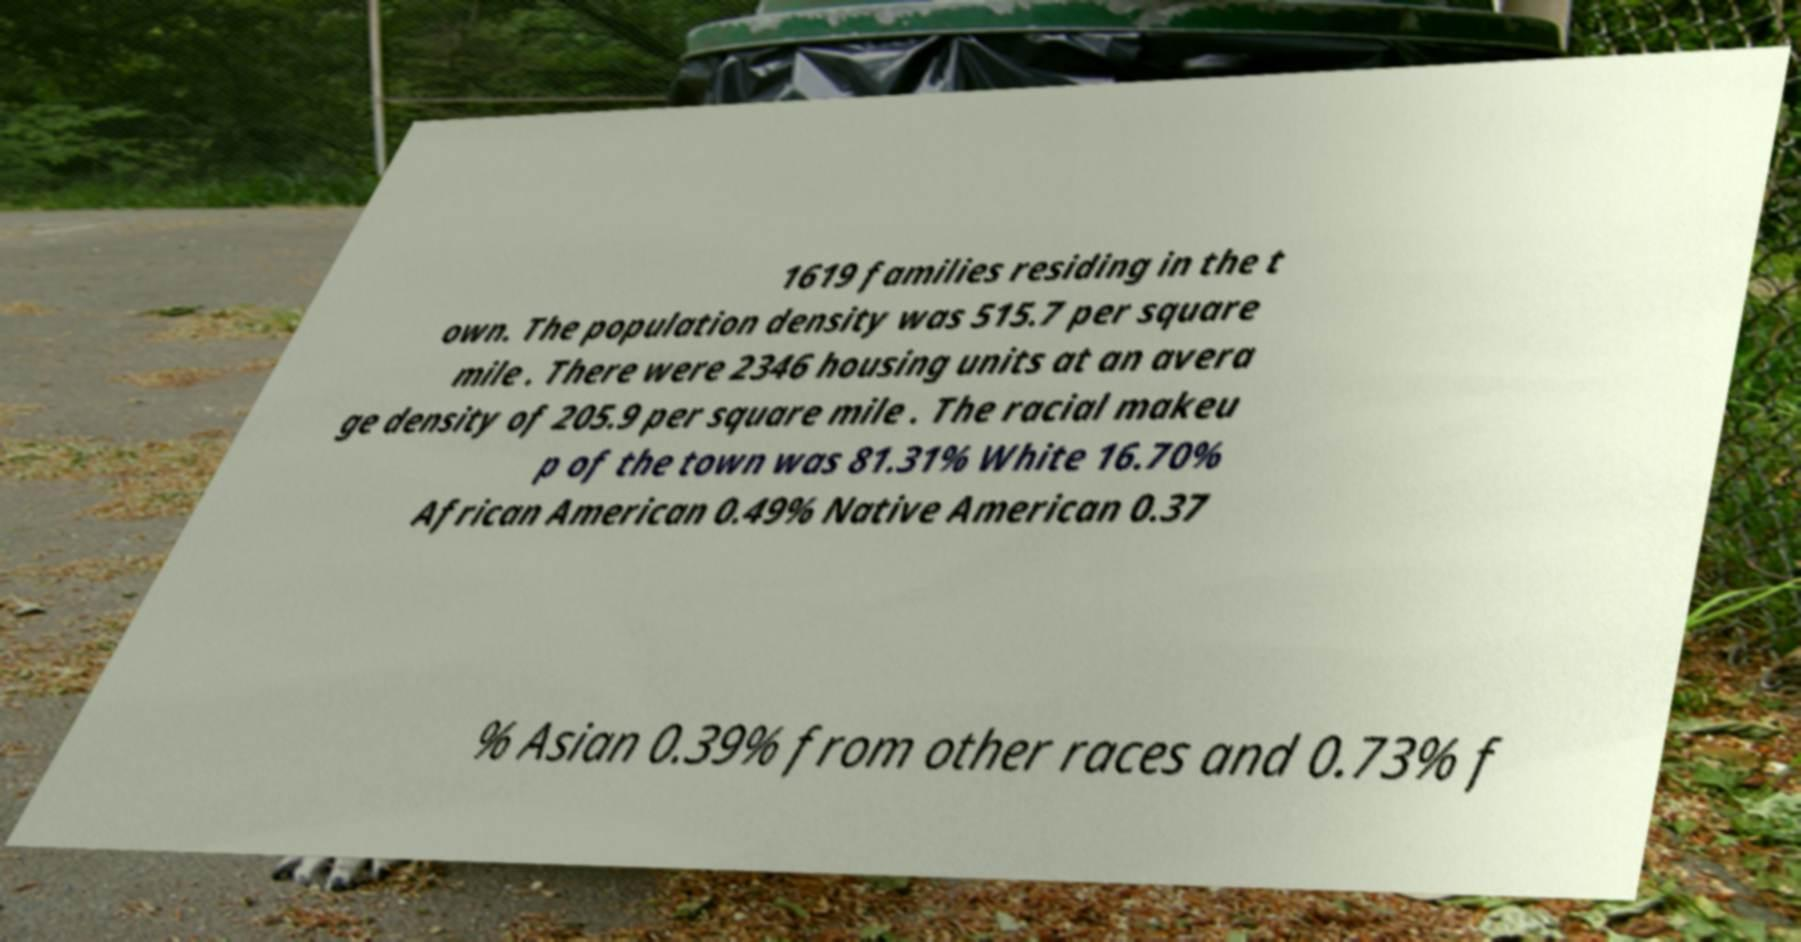I need the written content from this picture converted into text. Can you do that? 1619 families residing in the t own. The population density was 515.7 per square mile . There were 2346 housing units at an avera ge density of 205.9 per square mile . The racial makeu p of the town was 81.31% White 16.70% African American 0.49% Native American 0.37 % Asian 0.39% from other races and 0.73% f 